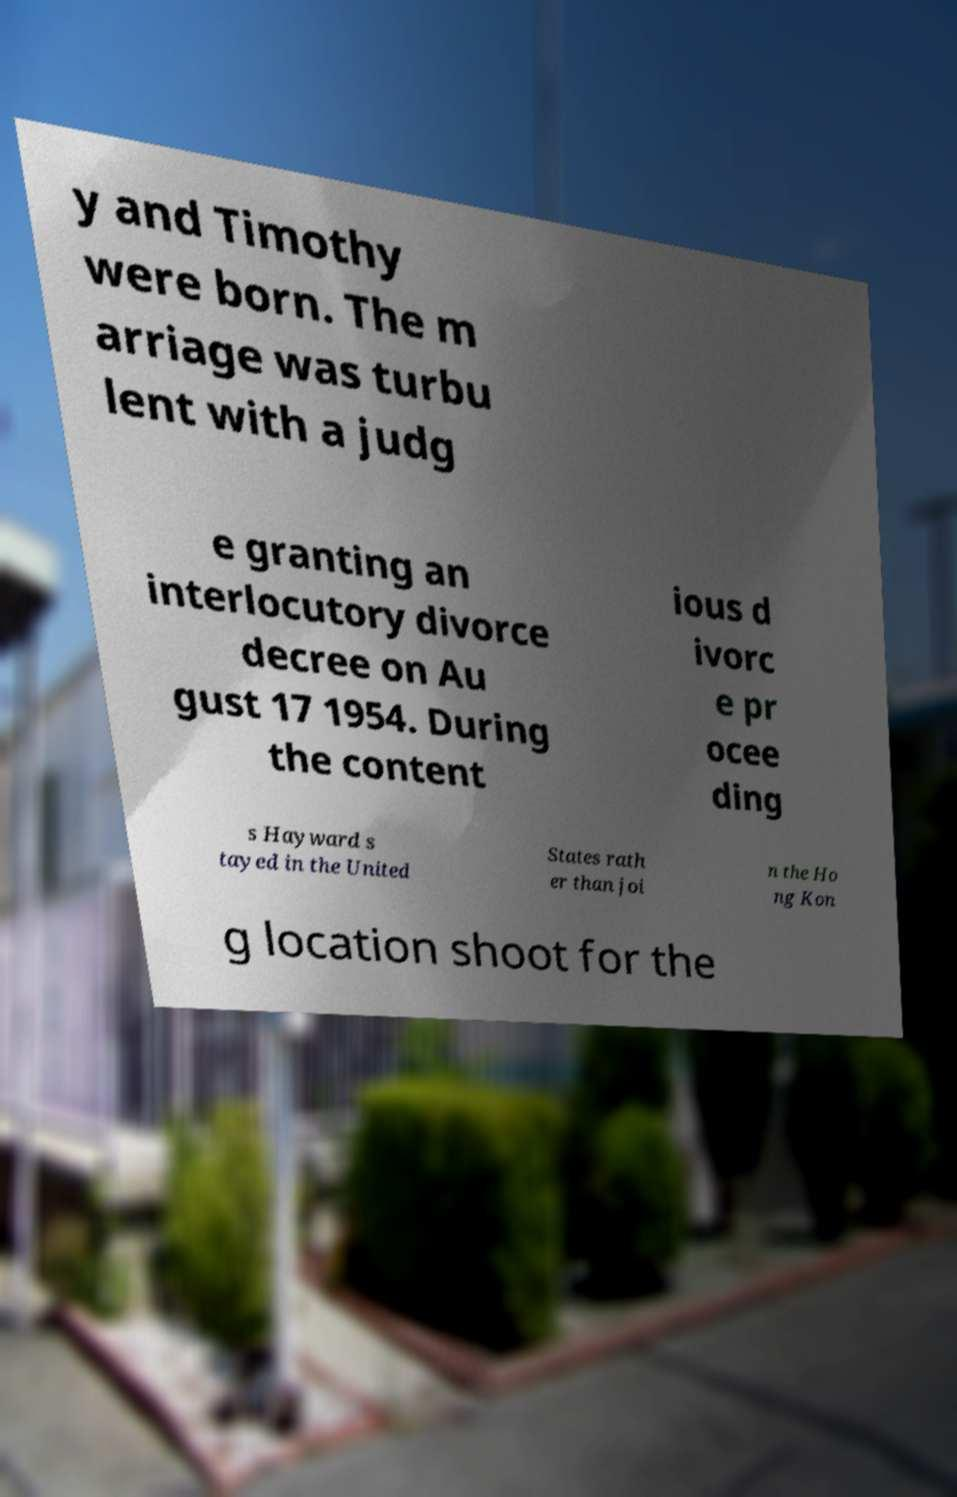Can you accurately transcribe the text from the provided image for me? y and Timothy were born. The m arriage was turbu lent with a judg e granting an interlocutory divorce decree on Au gust 17 1954. During the content ious d ivorc e pr ocee ding s Hayward s tayed in the United States rath er than joi n the Ho ng Kon g location shoot for the 